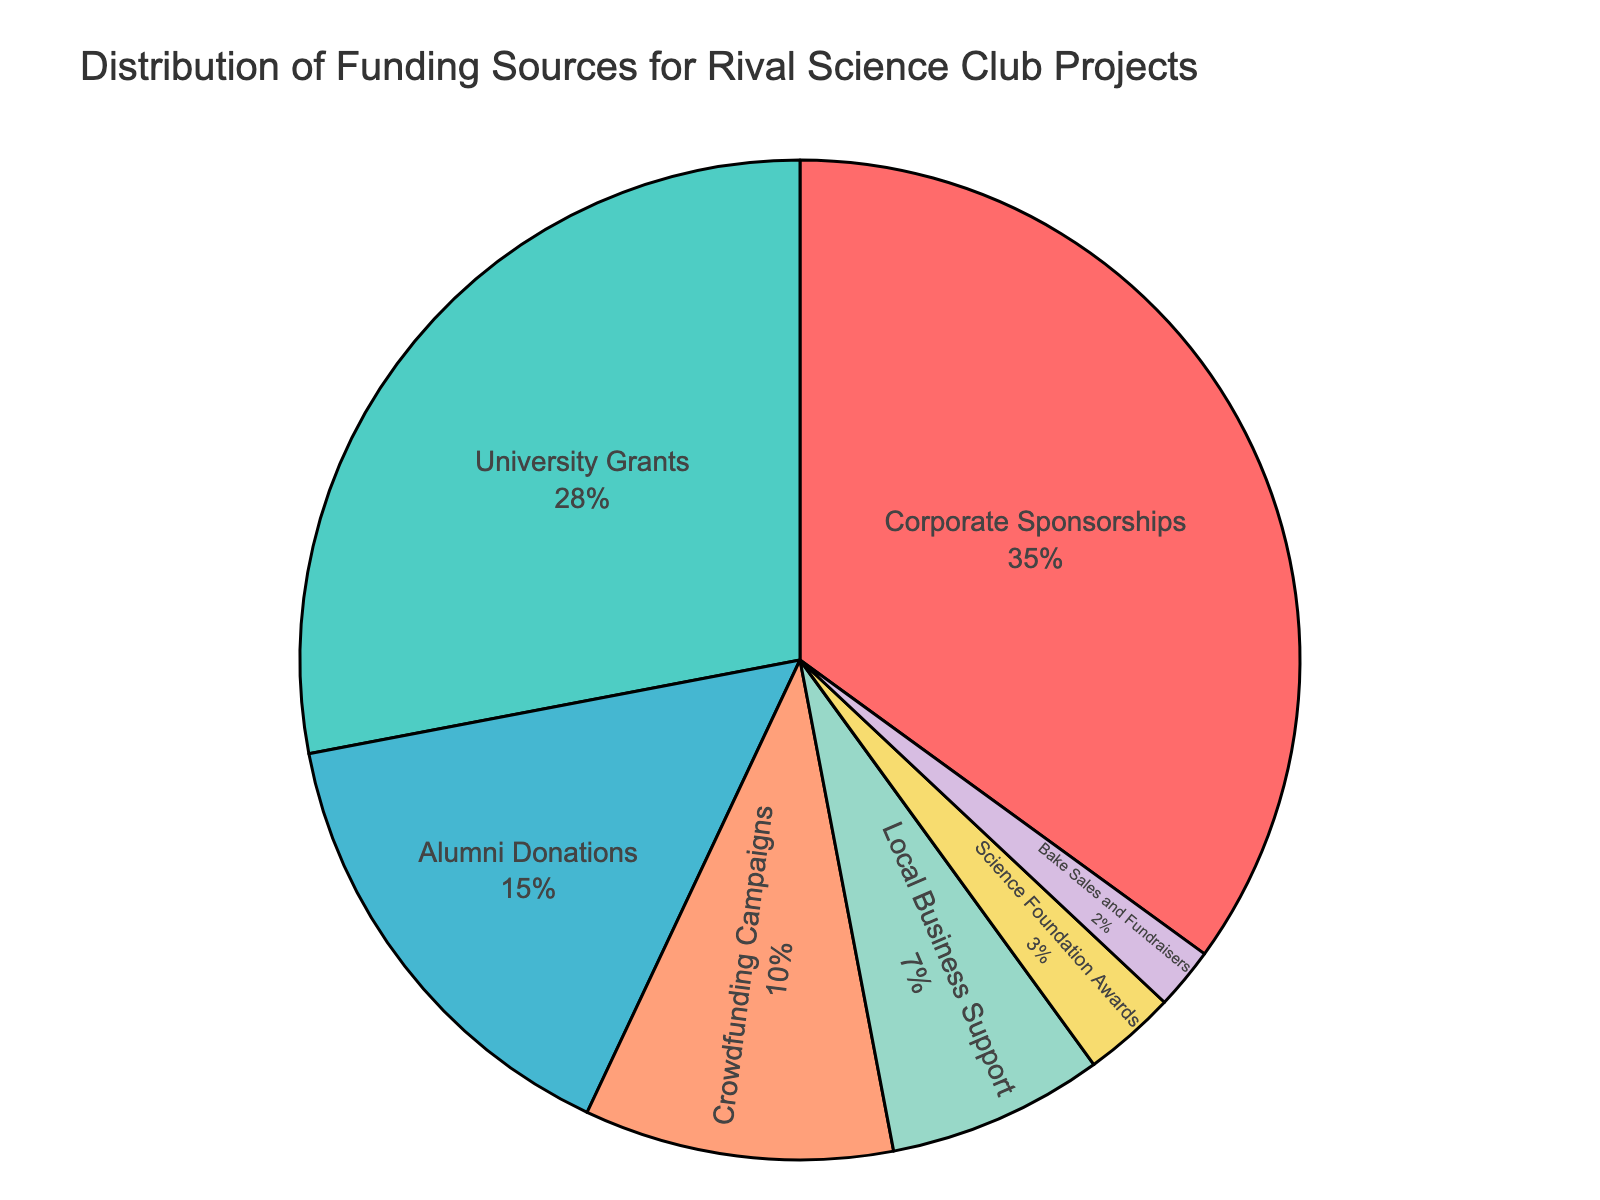Which funding source contributes the highest percentage? Looking at the pie chart, Corporate Sponsorships has the largest segment.
Answer: Corporate Sponsorships What's the combined percentage of funding from University Grants and Alumni Donations? The pie chart shows University Grants at 28% and Alumni Donations at 15%. Adding these two values gives 28 + 15 = 43.
Answer: 43% How much more funding is received from Corporate Sponsorships compared to Crowdfunding Campaigns? Corporate Sponsorships is 35% and Crowdfunding Campaigns is 10%. Subtracting these, 35 - 10 = 25.
Answer: 25% Which funding sources contribute less than 10% each? Observing the pie chart, the sources with segments smaller than 10% are Local Business Support (7%), Science Foundation Awards (3%) and Bake Sales and Fundraisers (2%).
Answer: Local Business Support, Science Foundation Awards, Bake Sales and Fundraisers What is the total percentage contributed by sources that give less than 10% funding? Adding the percentages of Local Business Support (7%), Science Foundation Awards (3%), and Bake Sales and Fundraisers (2%) gives 7 + 3 + 2 = 12.
Answer: 12% Compare the funding from Corporate Sponsorships and University Grants. Which one is higher and by how much? Corporate Sponsorships' funding is at 35% while University Grants are at 28%. The difference is 35 - 28 = 7.
Answer: Corporate Sponsorships by 7% Is the combined funding from Crowdfunding Campaigns and Local Business Support greater than funding from Alumni Donations? Crowdfunding Campaigns contribute 10% and Local Business Support 7%, adding them gives 10 + 7 = 17%. Alumni Donations contribute 15%. Comparing 17% and 15%, 17% is greater.
Answer: Yes What's the smallest funding source and its percentage? The smallest segment in the pie chart is for Bake Sales and Fundraisers at 2%.
Answer: Bake Sales and Fundraisers, 2% Which sources contribute more than 20% each? The pie chart shows Corporate Sponsorships at 35% and University Grants at 28%. Both are greater than 20%.
Answer: Corporate Sponsorships, University Grants What's the difference between the highest and the lowest funding sources? Corporate Sponsorships are the highest at 35%, and Bake Sales and Fundraisers are the lowest at 2%. Subtracting these, 35 - 2 = 33.
Answer: 33% 